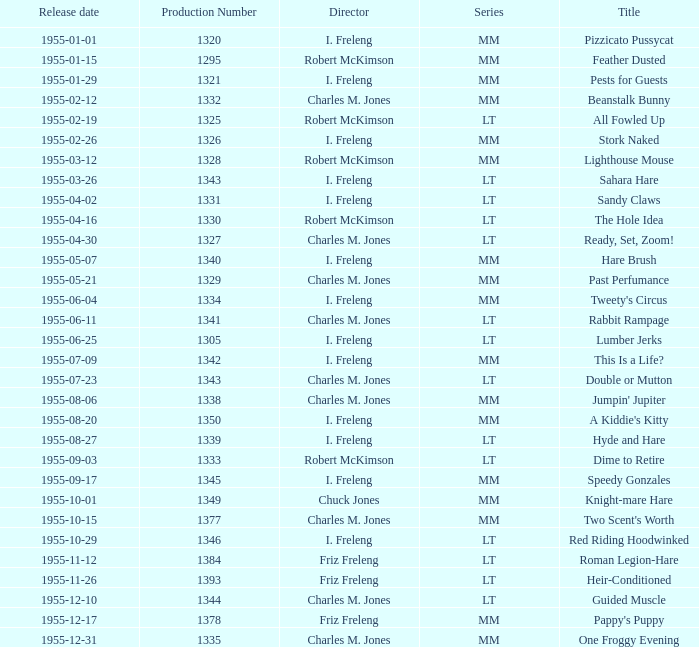What is the highest production number released on 1955-04-02 with i. freleng as the director? 1331.0. 